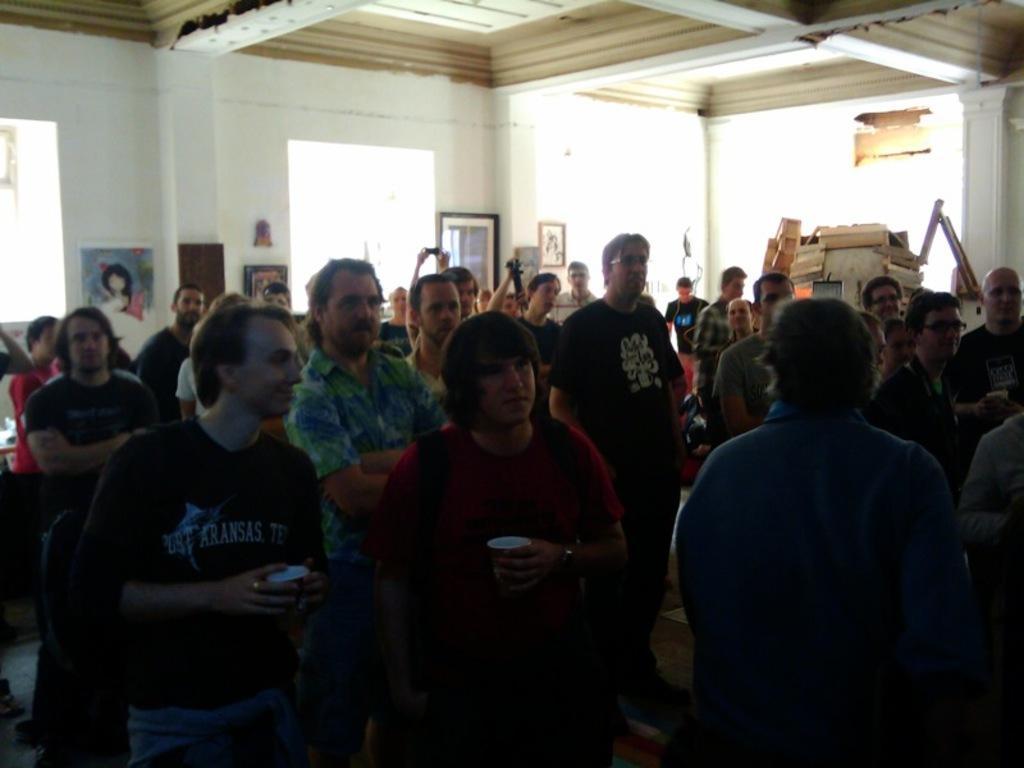Can you describe this image briefly? In this picture we can see a group of people standing on the floor and in the background we can see wall with frames and some objects. 